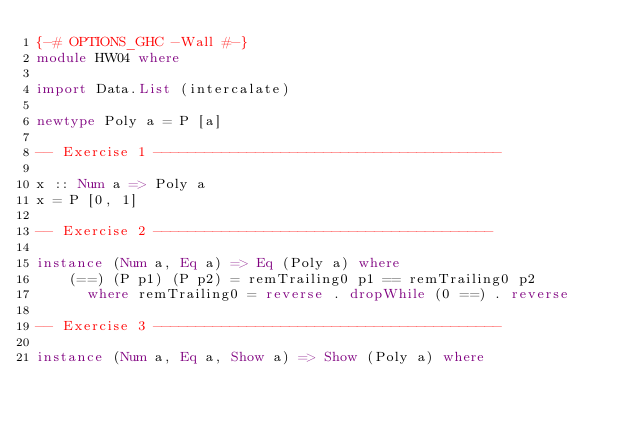<code> <loc_0><loc_0><loc_500><loc_500><_Haskell_>{-# OPTIONS_GHC -Wall #-}
module HW04 where

import Data.List (intercalate)

newtype Poly a = P [a]

-- Exercise 1 -----------------------------------------

x :: Num a => Poly a
x = P [0, 1]

-- Exercise 2 ----------------------------------------

instance (Num a, Eq a) => Eq (Poly a) where
    (==) (P p1) (P p2) = remTrailing0 p1 == remTrailing0 p2
      where remTrailing0 = reverse . dropWhile (0 ==) . reverse

-- Exercise 3 -----------------------------------------

instance (Num a, Eq a, Show a) => Show (Poly a) where</code> 